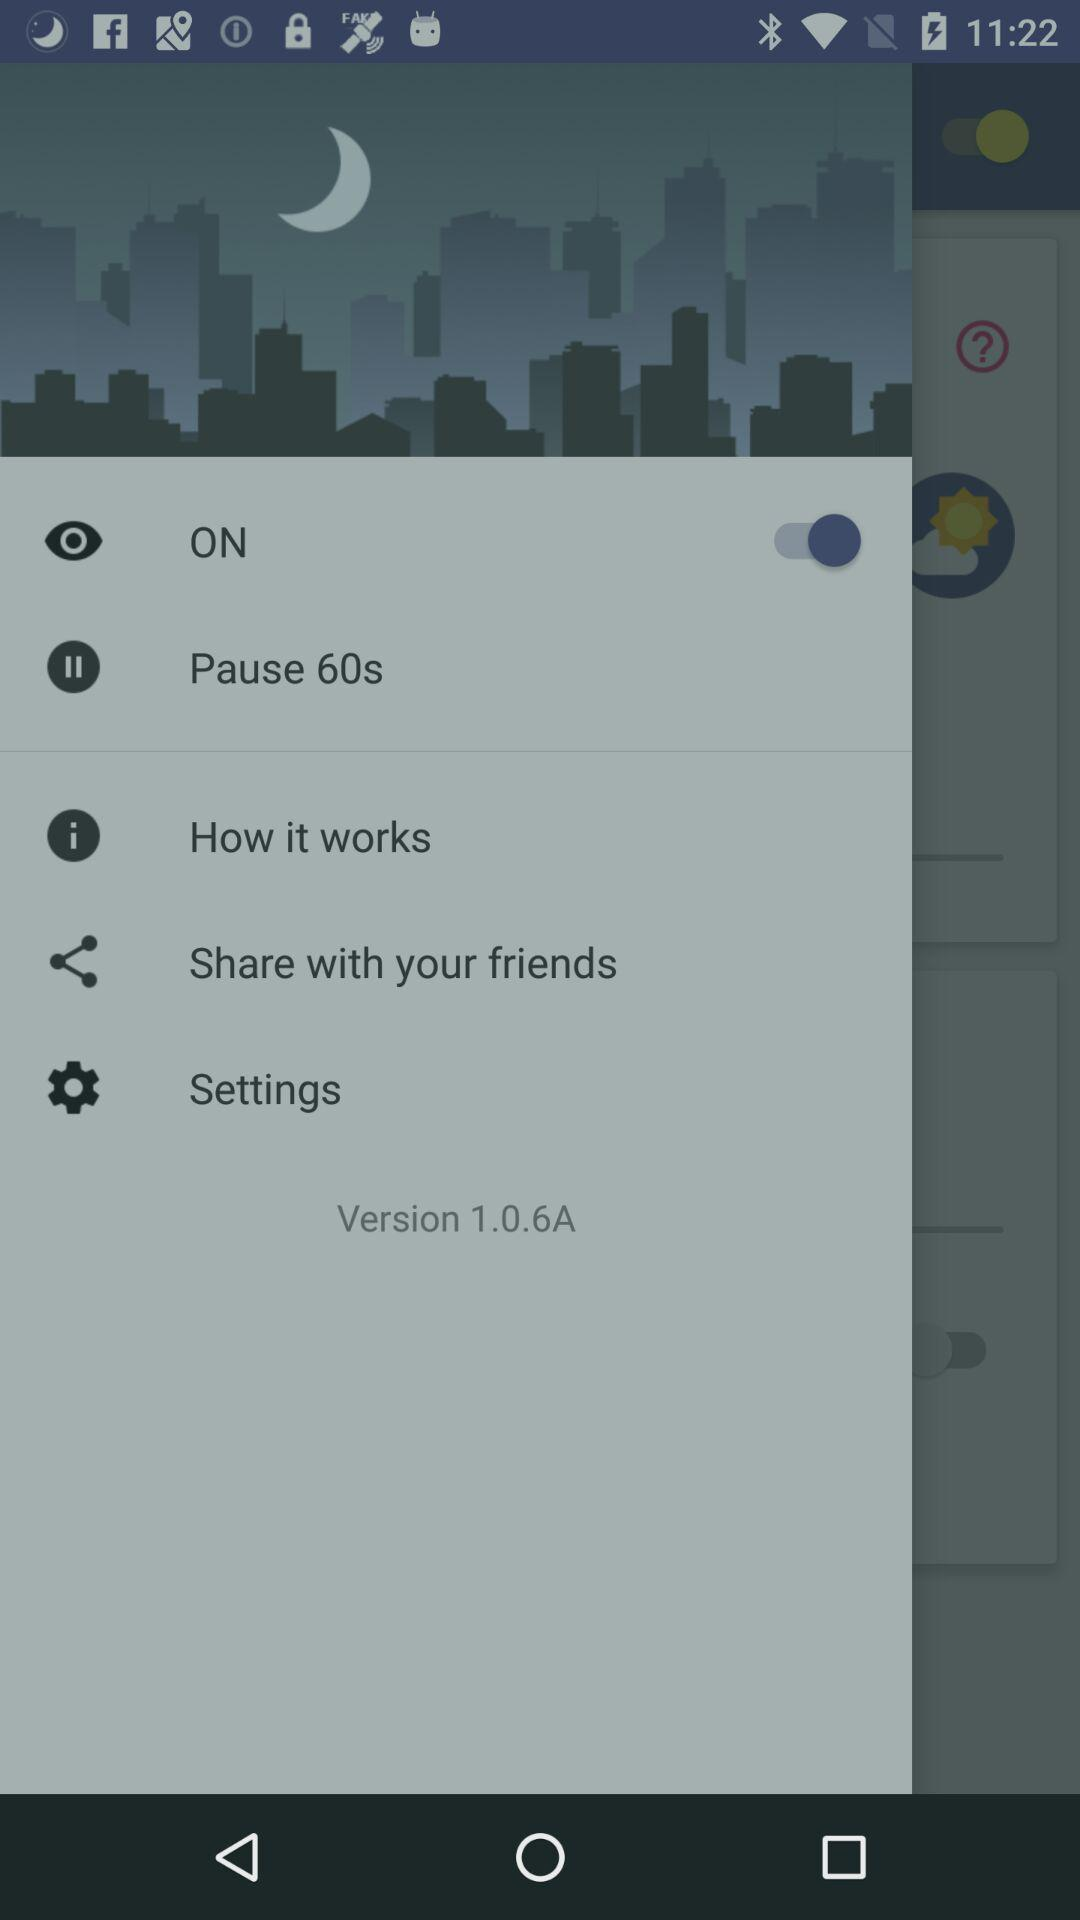What is the version of the app? The version of the app is 1.0.6A. 